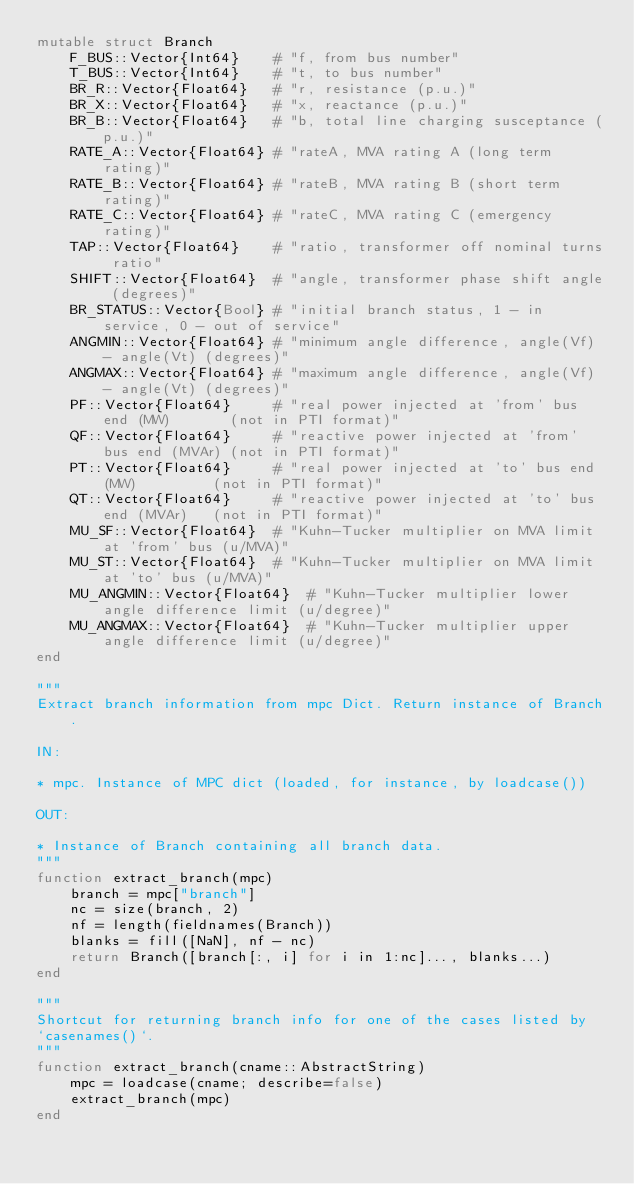Convert code to text. <code><loc_0><loc_0><loc_500><loc_500><_Julia_>mutable struct Branch
    F_BUS::Vector{Int64}    # "f, from bus number"
    T_BUS::Vector{Int64}    # "t, to bus number"
    BR_R::Vector{Float64}   # "r, resistance (p.u.)"
    BR_X::Vector{Float64}   # "x, reactance (p.u.)"
    BR_B::Vector{Float64}   # "b, total line charging susceptance (p.u.)"
    RATE_A::Vector{Float64} # "rateA, MVA rating A (long term rating)"
    RATE_B::Vector{Float64} # "rateB, MVA rating B (short term rating)"
    RATE_C::Vector{Float64} # "rateC, MVA rating C (emergency rating)"
    TAP::Vector{Float64}    # "ratio, transformer off nominal turns ratio"
    SHIFT::Vector{Float64}  # "angle, transformer phase shift angle (degrees)"
    BR_STATUS::Vector{Bool} # "initial branch status, 1 - in service, 0 - out of service"
    ANGMIN::Vector{Float64} # "minimum angle difference, angle(Vf) - angle(Vt) (degrees)"
    ANGMAX::Vector{Float64} # "maximum angle difference, angle(Vf) - angle(Vt) (degrees)"
    PF::Vector{Float64}     # "real power injected at 'from' bus end (MW)       (not in PTI format)"
    QF::Vector{Float64}     # "reactive power injected at 'from' bus end (MVAr) (not in PTI format)"
    PT::Vector{Float64}     # "real power injected at 'to' bus end (MW)         (not in PTI format)"
    QT::Vector{Float64}     # "reactive power injected at 'to' bus end (MVAr)   (not in PTI format)"
    MU_SF::Vector{Float64}  # "Kuhn-Tucker multiplier on MVA limit at 'from' bus (u/MVA)"
    MU_ST::Vector{Float64}  # "Kuhn-Tucker multiplier on MVA limit at 'to' bus (u/MVA)"
    MU_ANGMIN::Vector{Float64}  # "Kuhn-Tucker multiplier lower angle difference limit (u/degree)"
    MU_ANGMAX::Vector{Float64}  # "Kuhn-Tucker multiplier upper angle difference limit (u/degree)"
end

"""
Extract branch information from mpc Dict. Return instance of Branch.

IN:

* mpc. Instance of MPC dict (loaded, for instance, by loadcase())

OUT:

* Instance of Branch containing all branch data.
"""
function extract_branch(mpc)
    branch = mpc["branch"]
    nc = size(branch, 2)
    nf = length(fieldnames(Branch))
    blanks = fill([NaN], nf - nc)
    return Branch([branch[:, i] for i in 1:nc]..., blanks...)
end

"""
Shortcut for returning branch info for one of the cases listed by
`casenames()`.
"""
function extract_branch(cname::AbstractString)
    mpc = loadcase(cname; describe=false)
    extract_branch(mpc)
end
</code> 